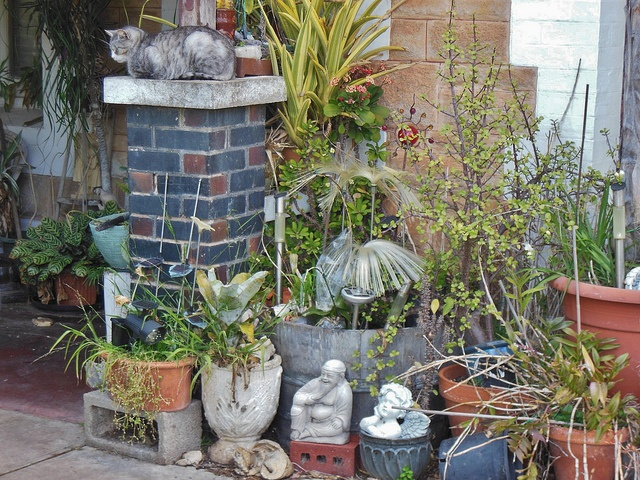Describe the objects in this image and their specific colors. I can see potted plant in gray, olive, darkgray, and darkgreen tones, potted plant in gray, darkgray, darkgreen, and black tones, potted plant in gray, black, and olive tones, potted plant in gray, olive, brown, and tan tones, and potted plant in gray, darkgray, lightgray, and olive tones in this image. 